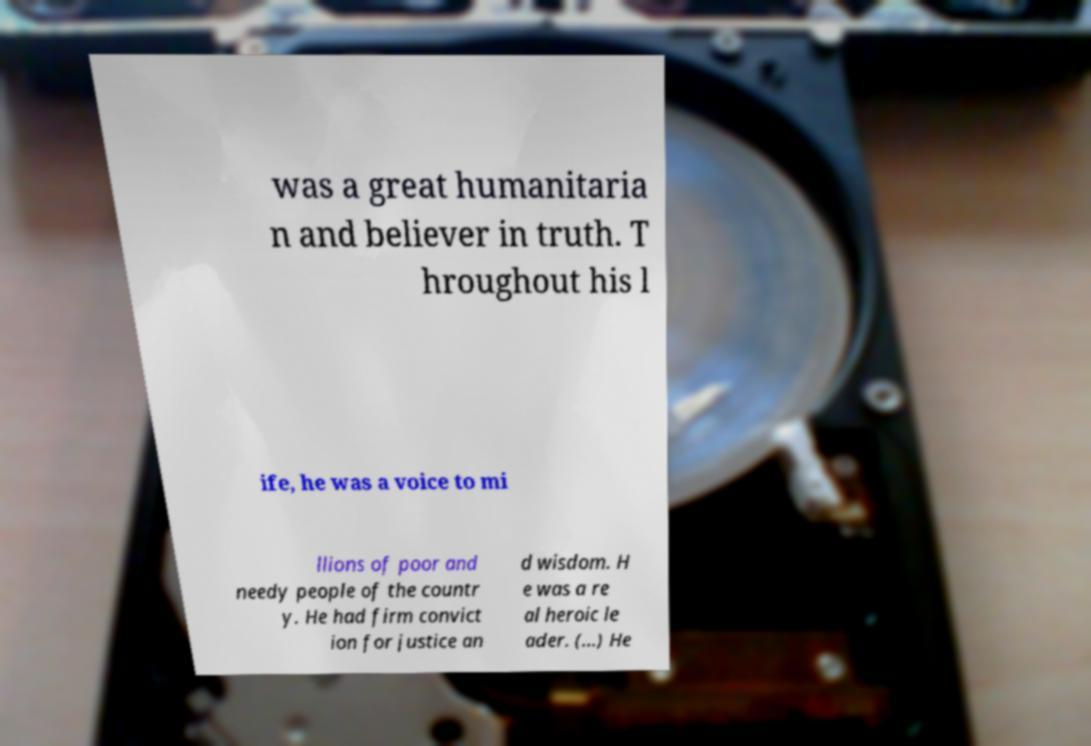Can you read and provide the text displayed in the image?This photo seems to have some interesting text. Can you extract and type it out for me? was a great humanitaria n and believer in truth. T hroughout his l ife, he was a voice to mi llions of poor and needy people of the countr y. He had firm convict ion for justice an d wisdom. H e was a re al heroic le ader. (...) He 